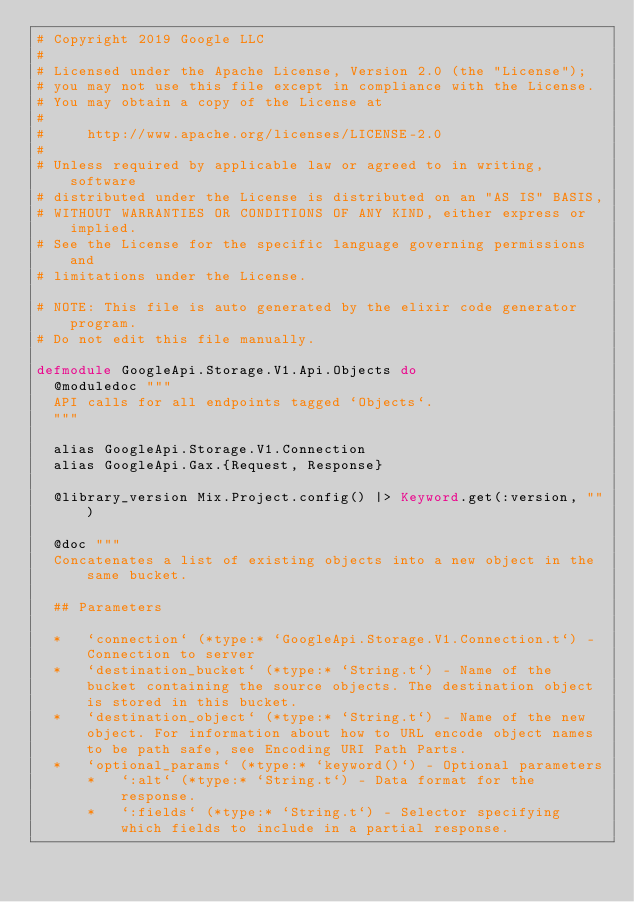<code> <loc_0><loc_0><loc_500><loc_500><_Elixir_># Copyright 2019 Google LLC
#
# Licensed under the Apache License, Version 2.0 (the "License");
# you may not use this file except in compliance with the License.
# You may obtain a copy of the License at
#
#     http://www.apache.org/licenses/LICENSE-2.0
#
# Unless required by applicable law or agreed to in writing, software
# distributed under the License is distributed on an "AS IS" BASIS,
# WITHOUT WARRANTIES OR CONDITIONS OF ANY KIND, either express or implied.
# See the License for the specific language governing permissions and
# limitations under the License.

# NOTE: This file is auto generated by the elixir code generator program.
# Do not edit this file manually.

defmodule GoogleApi.Storage.V1.Api.Objects do
  @moduledoc """
  API calls for all endpoints tagged `Objects`.
  """

  alias GoogleApi.Storage.V1.Connection
  alias GoogleApi.Gax.{Request, Response}

  @library_version Mix.Project.config() |> Keyword.get(:version, "")

  @doc """
  Concatenates a list of existing objects into a new object in the same bucket.

  ## Parameters

  *   `connection` (*type:* `GoogleApi.Storage.V1.Connection.t`) - Connection to server
  *   `destination_bucket` (*type:* `String.t`) - Name of the bucket containing the source objects. The destination object is stored in this bucket.
  *   `destination_object` (*type:* `String.t`) - Name of the new object. For information about how to URL encode object names to be path safe, see Encoding URI Path Parts.
  *   `optional_params` (*type:* `keyword()`) - Optional parameters
      *   `:alt` (*type:* `String.t`) - Data format for the response.
      *   `:fields` (*type:* `String.t`) - Selector specifying which fields to include in a partial response.</code> 